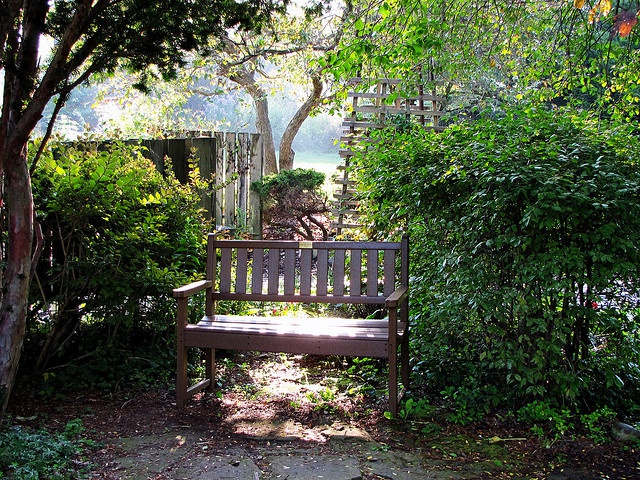Describe the objects in this image and their specific colors. I can see a bench in black, gray, and white tones in this image. 